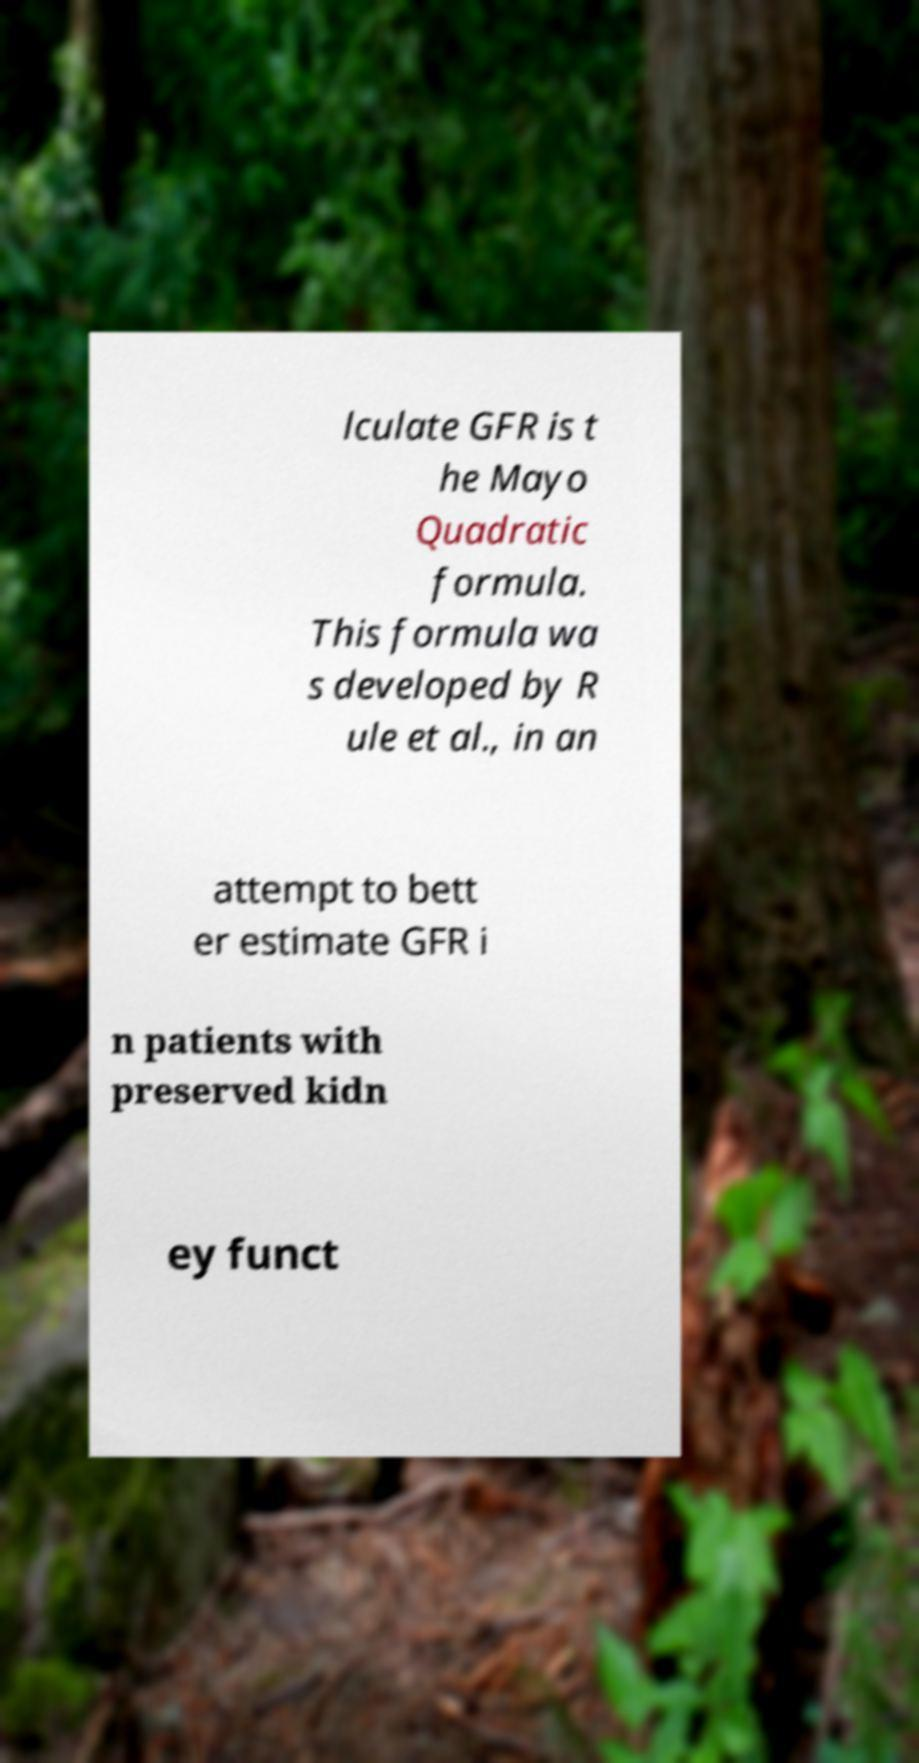For documentation purposes, I need the text within this image transcribed. Could you provide that? lculate GFR is t he Mayo Quadratic formula. This formula wa s developed by R ule et al., in an attempt to bett er estimate GFR i n patients with preserved kidn ey funct 